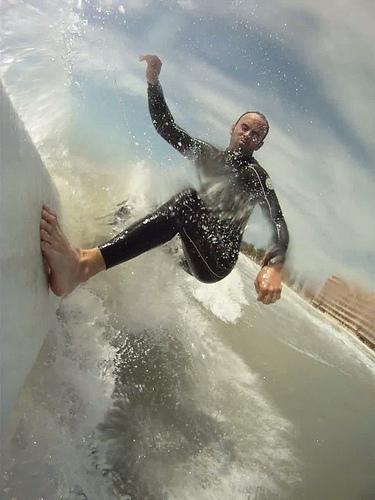What is the man wearing?
Give a very brief answer. Wetsuit. What is this man on?
Be succinct. Surfboard. Does he know what he is doing?
Answer briefly. Yes. 